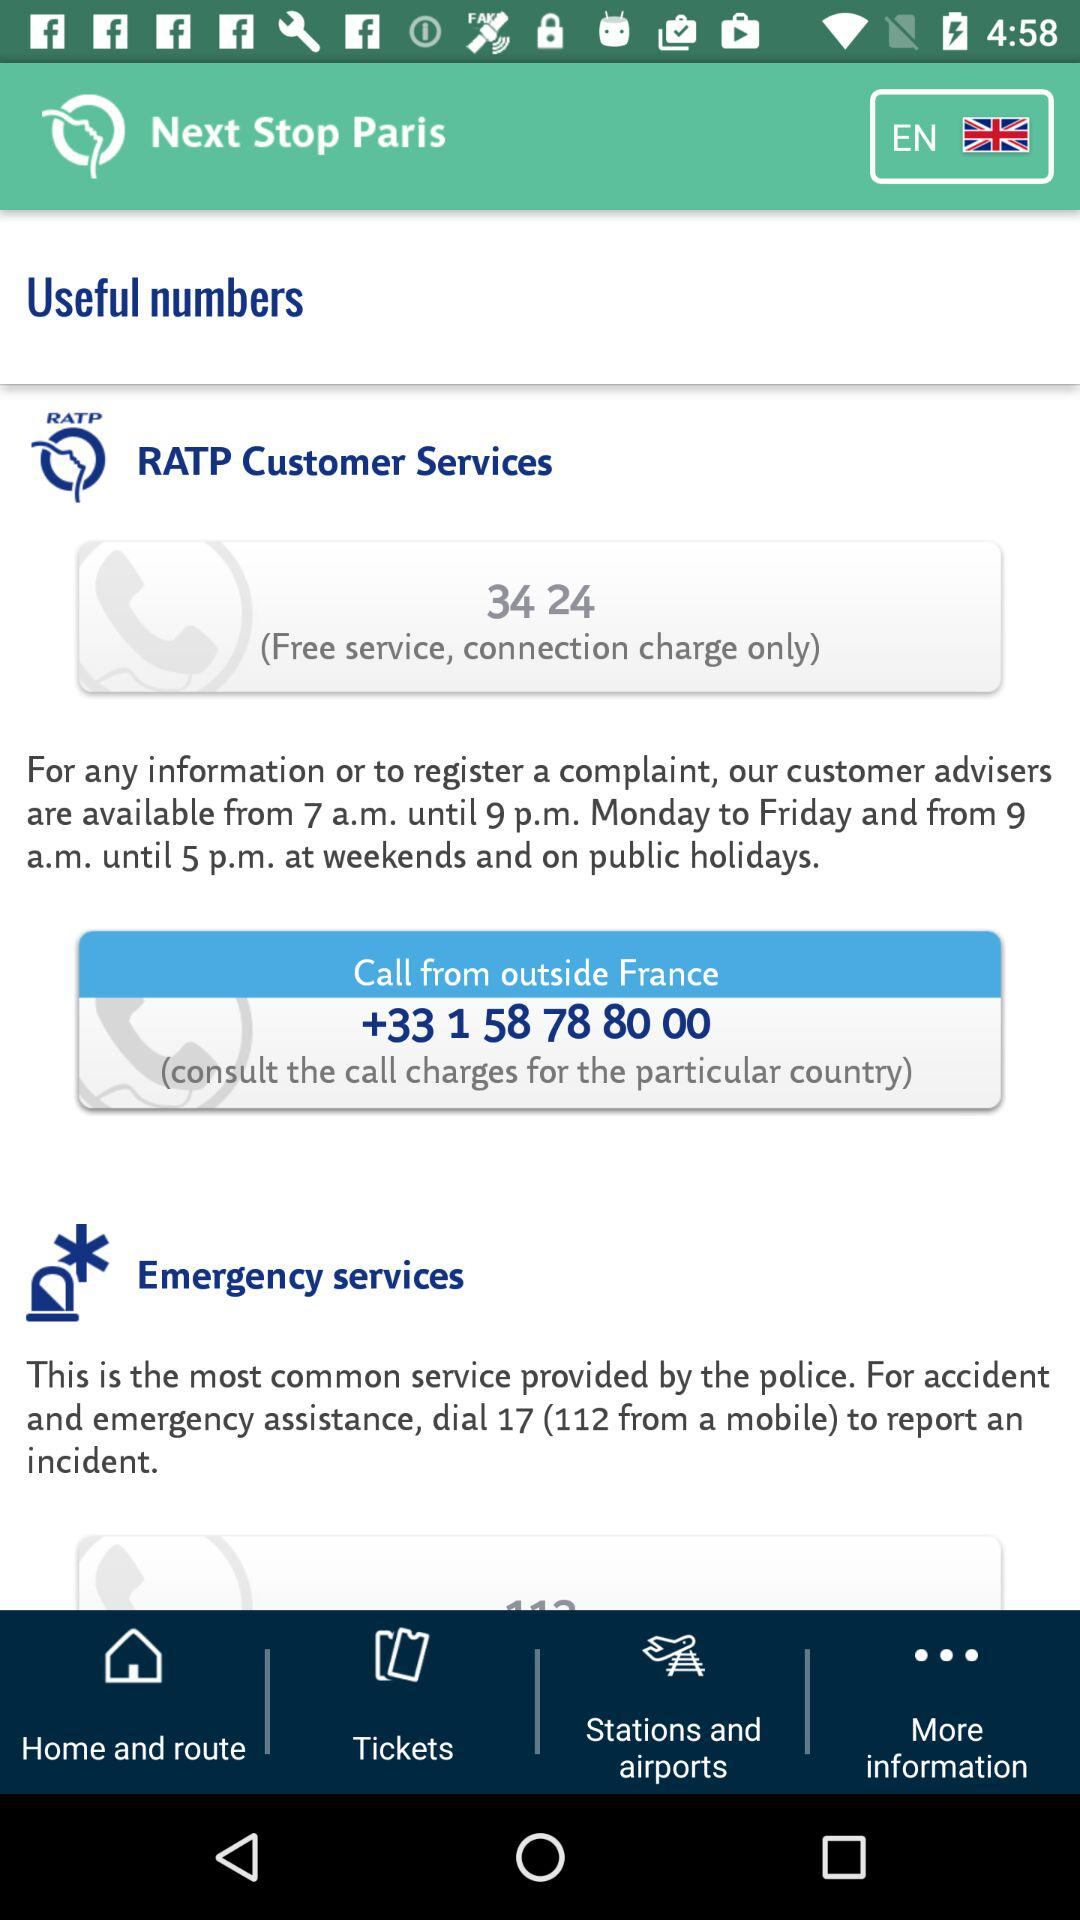What time are the customer advisers available? The customer advisers are available from 7 a.m. until 9 p.m., Monday to Friday and from 9 a.m. until 5 p.m. at weekends and on public holidays. 